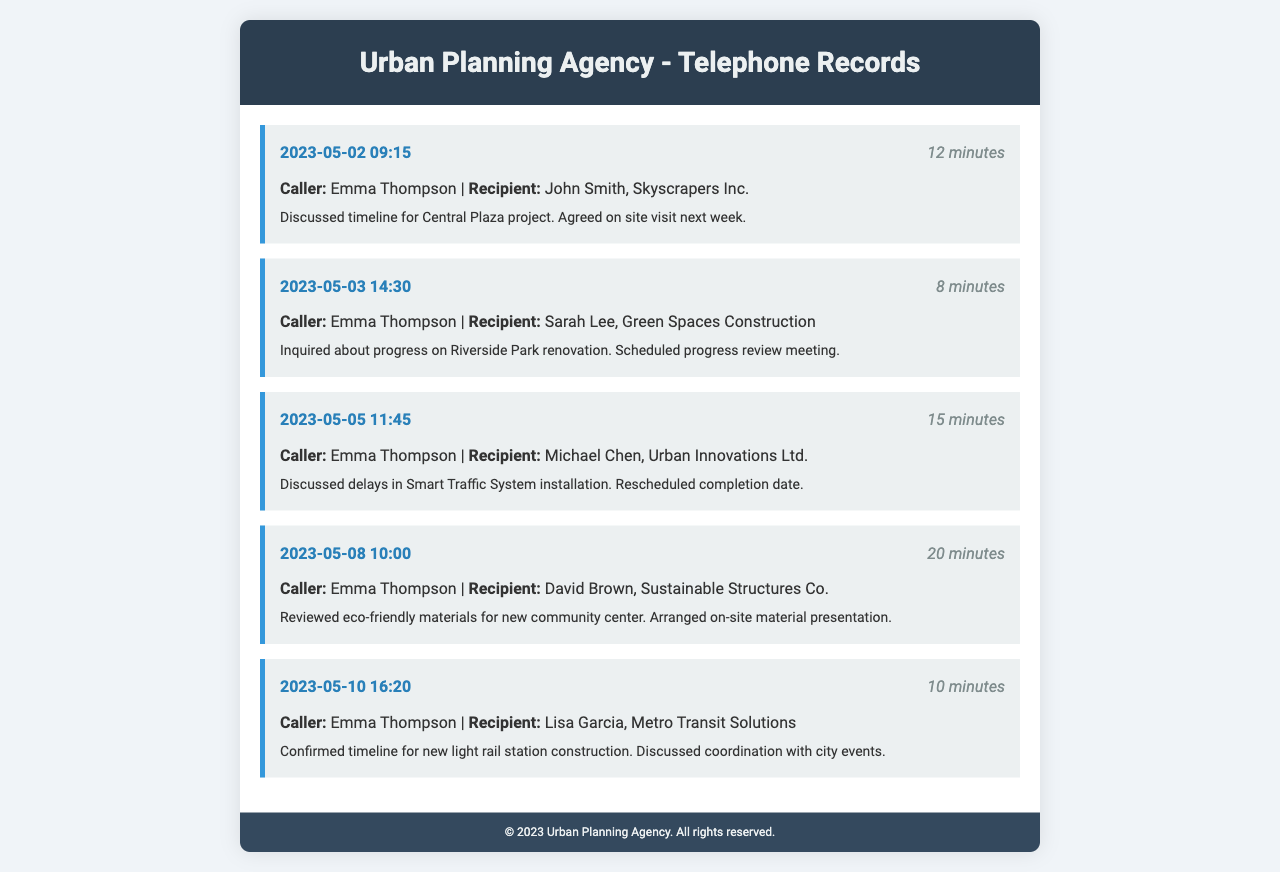What is the date of the first call? The first call is logged on May 2, 2023.
Answer: May 2, 2023 Who is the recipient of the call on May 5, 2023? The call on May 5, 2023, was to Michael Chen from Urban Innovations Ltd.
Answer: Michael Chen, Urban Innovations Ltd How long was the call on May 8, 2023? The duration of the call on May 8, 2023, was 20 minutes.
Answer: 20 minutes What project was discussed during the call with John Smith? The call with John Smith discussed the Central Plaza project timeline.
Answer: Central Plaza project How many minutes was the call with Sarah Lee? The call with Sarah Lee lasted for 8 minutes.
Answer: 8 minutes What was arranged during the call with David Brown? An on-site material presentation was arranged during the call with David Brown.
Answer: On-site material presentation Who is the caller for all records? The caller for all records is Emma Thompson.
Answer: Emma Thompson What issue was addressed during the call with Michael Chen? The delays in the Smart Traffic System installation were addressed during the call.
Answer: Delays in Smart Traffic System installation 